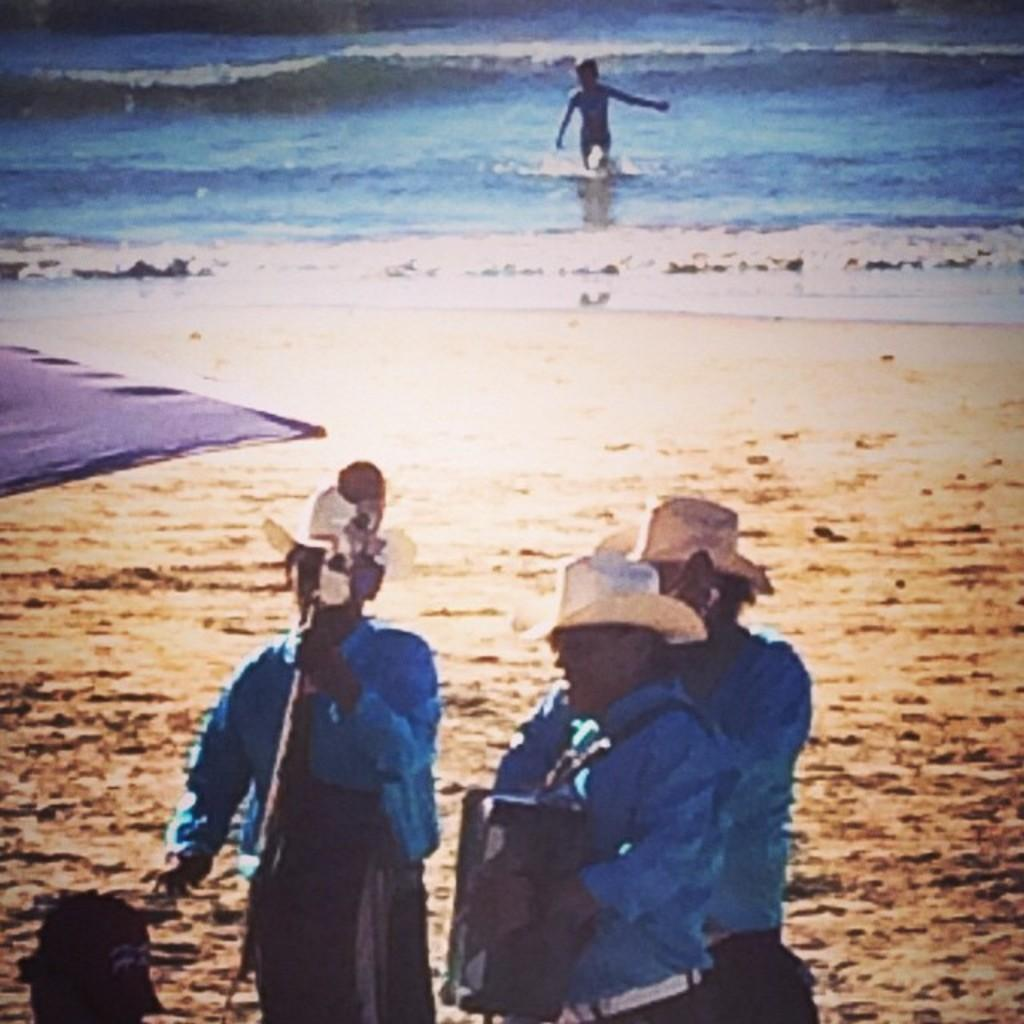Who or what can be seen in the image? There are people in the image. What are the people doing in the image? The people are holding objects. What natural feature is visible in the image? There is a body of water visible in the image. Can you describe the location of the person in relation to the water? There is a person near the water. What type of tooth is being used by the person near the water in the image? There is no tooth present in the image, and therefore no such activity can be observed. 